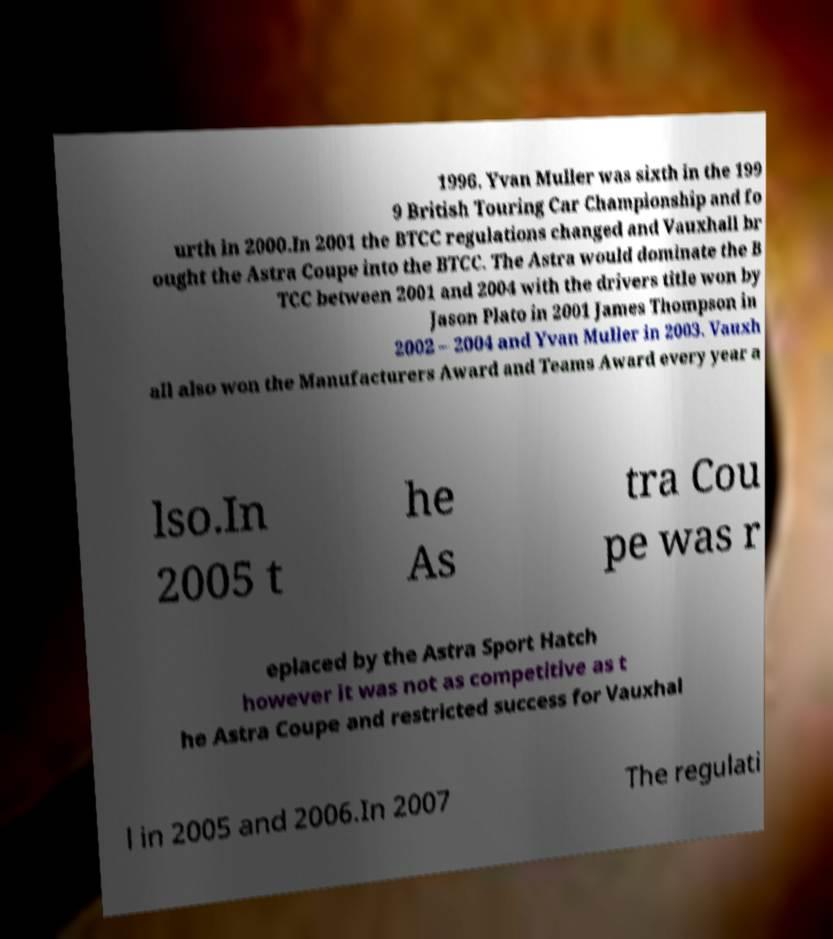What messages or text are displayed in this image? I need them in a readable, typed format. 1996. Yvan Muller was sixth in the 199 9 British Touring Car Championship and fo urth in 2000.In 2001 the BTCC regulations changed and Vauxhall br ought the Astra Coupe into the BTCC. The Astra would dominate the B TCC between 2001 and 2004 with the drivers title won by Jason Plato in 2001 James Thompson in 2002 – 2004 and Yvan Muller in 2003. Vauxh all also won the Manufacturers Award and Teams Award every year a lso.In 2005 t he As tra Cou pe was r eplaced by the Astra Sport Hatch however it was not as competitive as t he Astra Coupe and restricted success for Vauxhal l in 2005 and 2006.In 2007 The regulati 